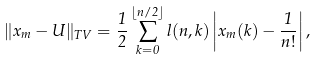Convert formula to latex. <formula><loc_0><loc_0><loc_500><loc_500>\| x _ { m } - U \| _ { T V } = \frac { 1 } { 2 } \sum _ { k = 0 } ^ { \lfloor n / 2 \rfloor } l ( n , k ) \left | x _ { m } ( k ) - \frac { 1 } { n ! } \right | ,</formula> 